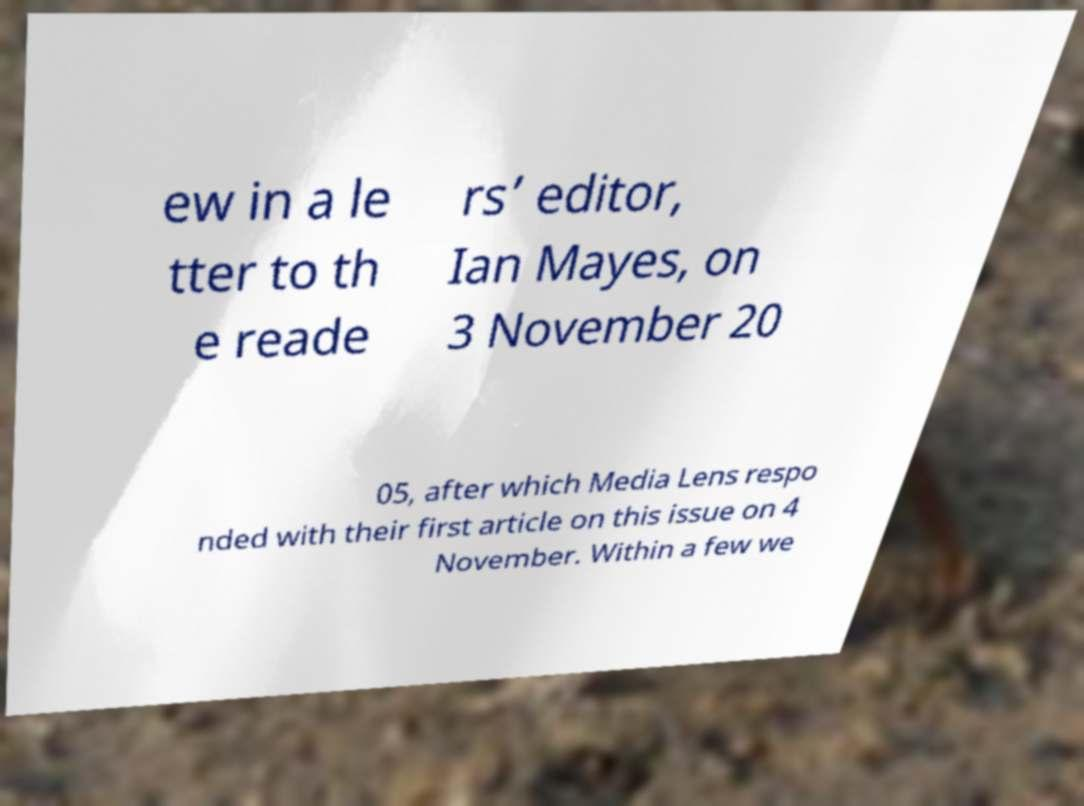Can you read and provide the text displayed in the image?This photo seems to have some interesting text. Can you extract and type it out for me? ew in a le tter to th e reade rs’ editor, Ian Mayes, on 3 November 20 05, after which Media Lens respo nded with their first article on this issue on 4 November. Within a few we 